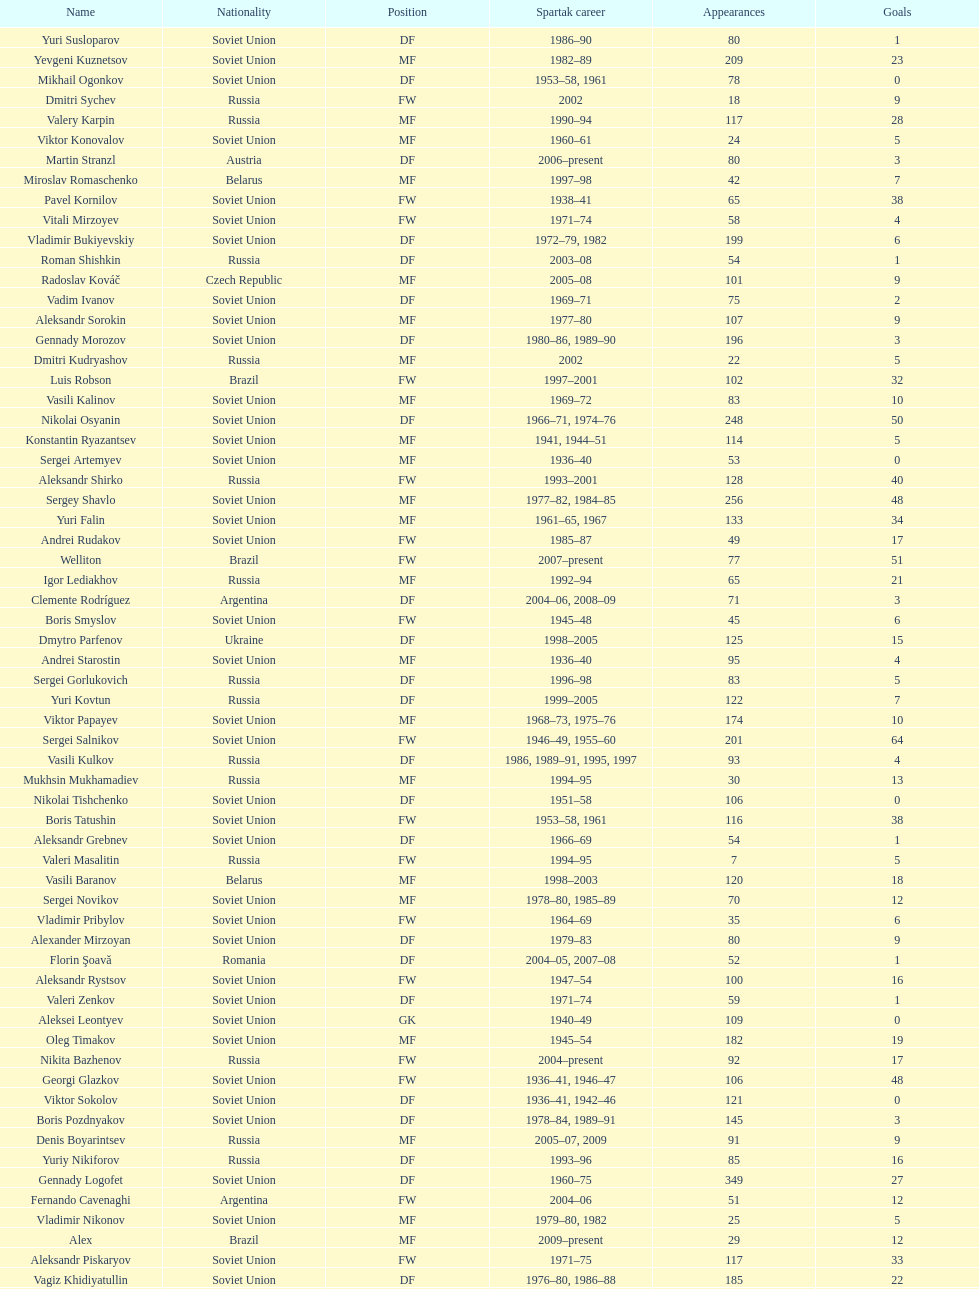Which player has the highest number of goals? Nikita Simonyan. 